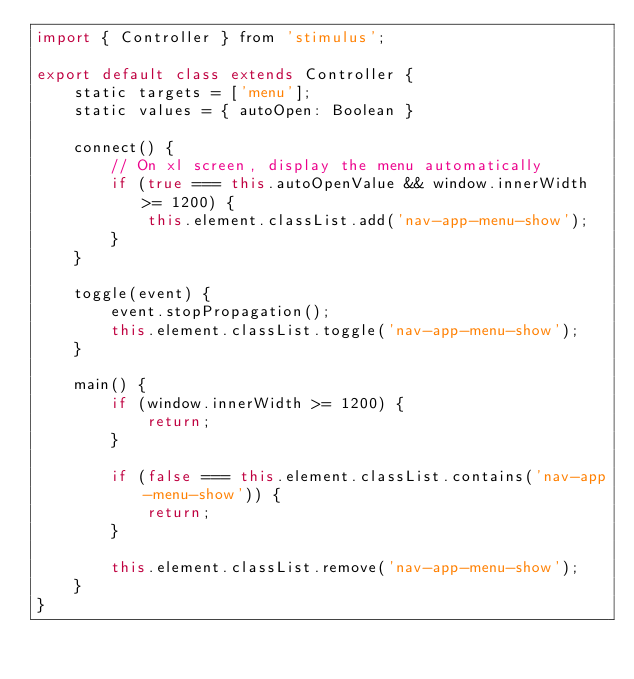Convert code to text. <code><loc_0><loc_0><loc_500><loc_500><_JavaScript_>import { Controller } from 'stimulus';

export default class extends Controller {
    static targets = ['menu'];
    static values = { autoOpen: Boolean }

    connect() {
        // On xl screen, display the menu automatically
        if (true === this.autoOpenValue && window.innerWidth >= 1200) {
            this.element.classList.add('nav-app-menu-show');
        }
    }

    toggle(event) {
        event.stopPropagation();
        this.element.classList.toggle('nav-app-menu-show');
    }

    main() {
        if (window.innerWidth >= 1200) {
            return;
        }

        if (false === this.element.classList.contains('nav-app-menu-show')) {
            return;
        }

        this.element.classList.remove('nav-app-menu-show');
    }
}
</code> 